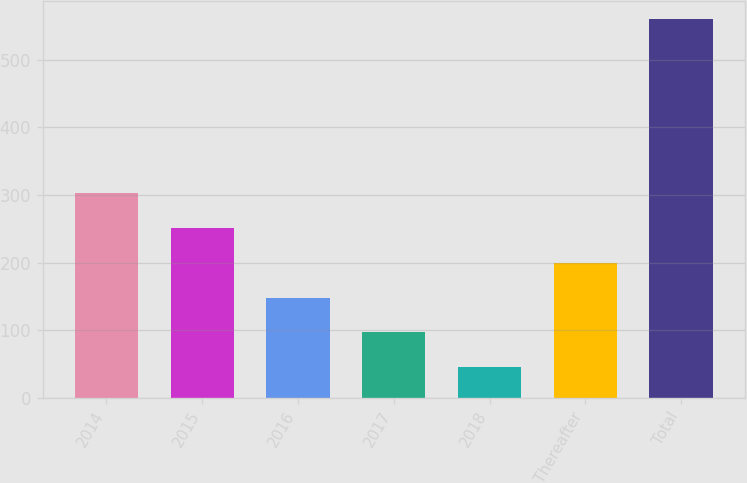Convert chart to OTSL. <chart><loc_0><loc_0><loc_500><loc_500><bar_chart><fcel>2014<fcel>2015<fcel>2016<fcel>2017<fcel>2018<fcel>Thereafter<fcel>Total<nl><fcel>302.5<fcel>251<fcel>148<fcel>96.5<fcel>45<fcel>199.5<fcel>560<nl></chart> 